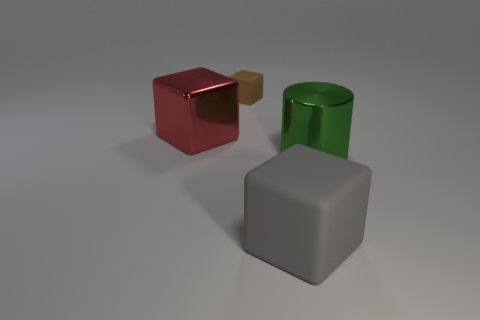What is the size of the brown object that is the same shape as the large red object?
Your answer should be compact. Small. Are there any other things that have the same size as the brown block?
Offer a very short reply. No. What material is the cube in front of the thing to the left of the tiny brown rubber block?
Ensure brevity in your answer.  Rubber. Is the shape of the small object the same as the big red thing?
Provide a succinct answer. Yes. What number of objects are both in front of the red shiny object and left of the green metallic object?
Offer a terse response. 1. Are there an equal number of matte blocks that are in front of the large metallic block and tiny objects in front of the gray object?
Keep it short and to the point. No. Does the object that is right of the big gray matte block have the same size as the matte block that is behind the large green cylinder?
Provide a short and direct response. No. What is the thing that is both on the right side of the large shiny block and left of the large gray matte block made of?
Offer a very short reply. Rubber. Is the number of small blocks less than the number of tiny purple matte cylinders?
Your answer should be compact. No. What is the size of the matte object behind the big block behind the cylinder?
Make the answer very short. Small. 